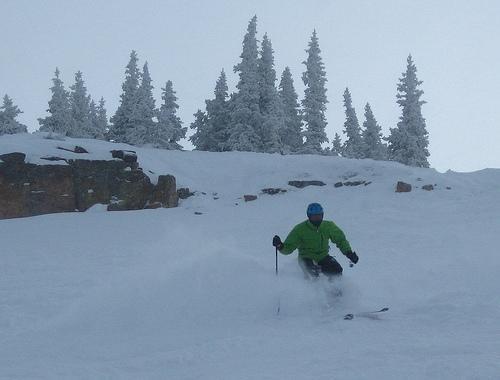How many people skiing?
Give a very brief answer. 1. 